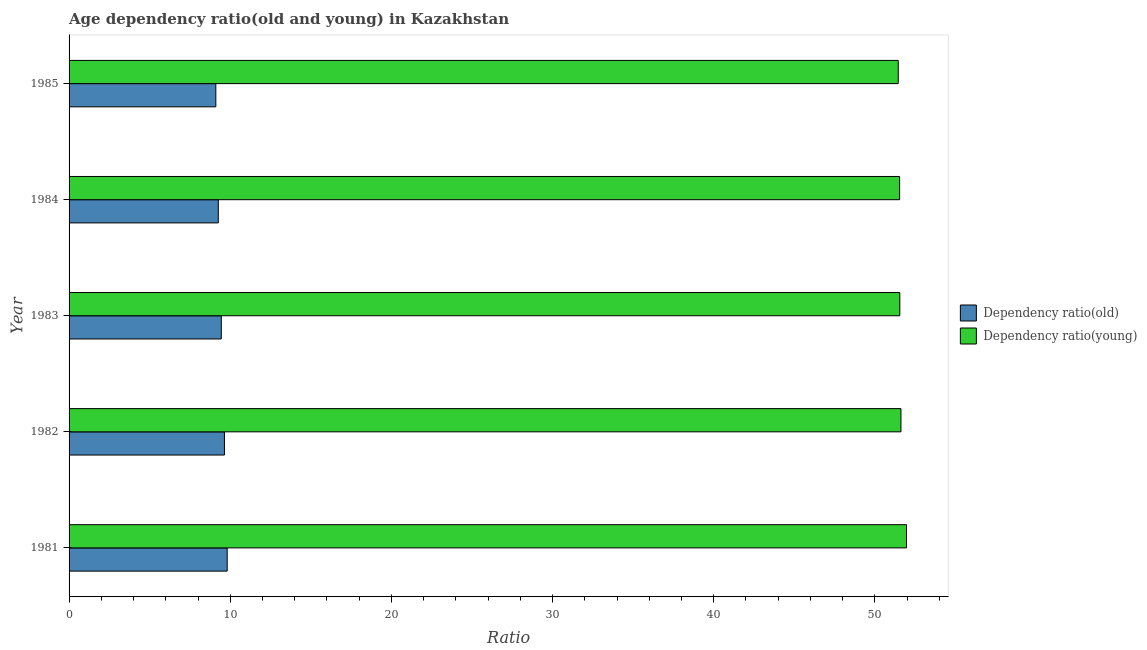How many different coloured bars are there?
Your answer should be compact. 2. How many groups of bars are there?
Offer a very short reply. 5. How many bars are there on the 4th tick from the bottom?
Keep it short and to the point. 2. What is the label of the 3rd group of bars from the top?
Provide a short and direct response. 1983. What is the age dependency ratio(young) in 1981?
Offer a terse response. 51.96. Across all years, what is the maximum age dependency ratio(old)?
Ensure brevity in your answer.  9.81. Across all years, what is the minimum age dependency ratio(old)?
Your answer should be compact. 9.11. In which year was the age dependency ratio(young) maximum?
Give a very brief answer. 1981. What is the total age dependency ratio(young) in the graph?
Your response must be concise. 258.12. What is the difference between the age dependency ratio(old) in 1983 and that in 1985?
Ensure brevity in your answer.  0.34. What is the difference between the age dependency ratio(young) in 1981 and the age dependency ratio(old) in 1984?
Make the answer very short. 42.7. What is the average age dependency ratio(old) per year?
Keep it short and to the point. 9.45. In the year 1981, what is the difference between the age dependency ratio(old) and age dependency ratio(young)?
Give a very brief answer. -42.15. In how many years, is the age dependency ratio(young) greater than 44 ?
Offer a terse response. 5. Is the age dependency ratio(old) in 1982 less than that in 1984?
Provide a short and direct response. No. Is the difference between the age dependency ratio(young) in 1982 and 1983 greater than the difference between the age dependency ratio(old) in 1982 and 1983?
Give a very brief answer. No. What is the difference between the highest and the second highest age dependency ratio(young)?
Provide a succinct answer. 0.34. What is the difference between the highest and the lowest age dependency ratio(young)?
Offer a terse response. 0.51. In how many years, is the age dependency ratio(young) greater than the average age dependency ratio(young) taken over all years?
Provide a succinct answer. 1. Is the sum of the age dependency ratio(young) in 1983 and 1985 greater than the maximum age dependency ratio(old) across all years?
Keep it short and to the point. Yes. What does the 2nd bar from the top in 1984 represents?
Make the answer very short. Dependency ratio(old). What does the 1st bar from the bottom in 1985 represents?
Your answer should be compact. Dependency ratio(old). How many years are there in the graph?
Provide a succinct answer. 5. Are the values on the major ticks of X-axis written in scientific E-notation?
Ensure brevity in your answer.  No. Does the graph contain any zero values?
Provide a succinct answer. No. What is the title of the graph?
Provide a succinct answer. Age dependency ratio(old and young) in Kazakhstan. Does "Researchers" appear as one of the legend labels in the graph?
Keep it short and to the point. No. What is the label or title of the X-axis?
Provide a succinct answer. Ratio. What is the label or title of the Y-axis?
Keep it short and to the point. Year. What is the Ratio in Dependency ratio(old) in 1981?
Your answer should be very brief. 9.81. What is the Ratio of Dependency ratio(young) in 1981?
Offer a very short reply. 51.96. What is the Ratio of Dependency ratio(old) in 1982?
Provide a succinct answer. 9.64. What is the Ratio in Dependency ratio(young) in 1982?
Your answer should be compact. 51.62. What is the Ratio of Dependency ratio(old) in 1983?
Provide a short and direct response. 9.45. What is the Ratio in Dependency ratio(young) in 1983?
Provide a succinct answer. 51.55. What is the Ratio in Dependency ratio(old) in 1984?
Give a very brief answer. 9.26. What is the Ratio in Dependency ratio(young) in 1984?
Ensure brevity in your answer.  51.54. What is the Ratio of Dependency ratio(old) in 1985?
Keep it short and to the point. 9.11. What is the Ratio in Dependency ratio(young) in 1985?
Provide a short and direct response. 51.45. Across all years, what is the maximum Ratio in Dependency ratio(old)?
Your answer should be compact. 9.81. Across all years, what is the maximum Ratio in Dependency ratio(young)?
Provide a succinct answer. 51.96. Across all years, what is the minimum Ratio in Dependency ratio(old)?
Offer a terse response. 9.11. Across all years, what is the minimum Ratio of Dependency ratio(young)?
Offer a terse response. 51.45. What is the total Ratio in Dependency ratio(old) in the graph?
Offer a very short reply. 47.27. What is the total Ratio of Dependency ratio(young) in the graph?
Make the answer very short. 258.12. What is the difference between the Ratio in Dependency ratio(old) in 1981 and that in 1982?
Your answer should be compact. 0.17. What is the difference between the Ratio in Dependency ratio(young) in 1981 and that in 1982?
Keep it short and to the point. 0.34. What is the difference between the Ratio in Dependency ratio(old) in 1981 and that in 1983?
Offer a very short reply. 0.37. What is the difference between the Ratio of Dependency ratio(young) in 1981 and that in 1983?
Your answer should be very brief. 0.41. What is the difference between the Ratio in Dependency ratio(old) in 1981 and that in 1984?
Give a very brief answer. 0.55. What is the difference between the Ratio of Dependency ratio(young) in 1981 and that in 1984?
Offer a very short reply. 0.43. What is the difference between the Ratio in Dependency ratio(old) in 1981 and that in 1985?
Your answer should be very brief. 0.7. What is the difference between the Ratio of Dependency ratio(young) in 1981 and that in 1985?
Provide a succinct answer. 0.51. What is the difference between the Ratio in Dependency ratio(old) in 1982 and that in 1983?
Keep it short and to the point. 0.2. What is the difference between the Ratio in Dependency ratio(young) in 1982 and that in 1983?
Keep it short and to the point. 0.07. What is the difference between the Ratio of Dependency ratio(old) in 1982 and that in 1984?
Offer a terse response. 0.38. What is the difference between the Ratio of Dependency ratio(young) in 1982 and that in 1984?
Offer a very short reply. 0.08. What is the difference between the Ratio of Dependency ratio(old) in 1982 and that in 1985?
Provide a short and direct response. 0.54. What is the difference between the Ratio in Dependency ratio(young) in 1982 and that in 1985?
Your answer should be very brief. 0.17. What is the difference between the Ratio in Dependency ratio(old) in 1983 and that in 1984?
Provide a short and direct response. 0.19. What is the difference between the Ratio of Dependency ratio(young) in 1983 and that in 1984?
Ensure brevity in your answer.  0.01. What is the difference between the Ratio in Dependency ratio(old) in 1983 and that in 1985?
Your answer should be compact. 0.34. What is the difference between the Ratio in Dependency ratio(young) in 1983 and that in 1985?
Keep it short and to the point. 0.1. What is the difference between the Ratio in Dependency ratio(old) in 1984 and that in 1985?
Make the answer very short. 0.15. What is the difference between the Ratio of Dependency ratio(young) in 1984 and that in 1985?
Your response must be concise. 0.09. What is the difference between the Ratio of Dependency ratio(old) in 1981 and the Ratio of Dependency ratio(young) in 1982?
Keep it short and to the point. -41.81. What is the difference between the Ratio in Dependency ratio(old) in 1981 and the Ratio in Dependency ratio(young) in 1983?
Provide a short and direct response. -41.74. What is the difference between the Ratio of Dependency ratio(old) in 1981 and the Ratio of Dependency ratio(young) in 1984?
Keep it short and to the point. -41.73. What is the difference between the Ratio of Dependency ratio(old) in 1981 and the Ratio of Dependency ratio(young) in 1985?
Your answer should be compact. -41.64. What is the difference between the Ratio of Dependency ratio(old) in 1982 and the Ratio of Dependency ratio(young) in 1983?
Ensure brevity in your answer.  -41.91. What is the difference between the Ratio in Dependency ratio(old) in 1982 and the Ratio in Dependency ratio(young) in 1984?
Offer a terse response. -41.9. What is the difference between the Ratio of Dependency ratio(old) in 1982 and the Ratio of Dependency ratio(young) in 1985?
Your answer should be compact. -41.81. What is the difference between the Ratio of Dependency ratio(old) in 1983 and the Ratio of Dependency ratio(young) in 1984?
Ensure brevity in your answer.  -42.09. What is the difference between the Ratio in Dependency ratio(old) in 1983 and the Ratio in Dependency ratio(young) in 1985?
Offer a terse response. -42.01. What is the difference between the Ratio in Dependency ratio(old) in 1984 and the Ratio in Dependency ratio(young) in 1985?
Provide a succinct answer. -42.19. What is the average Ratio of Dependency ratio(old) per year?
Offer a very short reply. 9.45. What is the average Ratio of Dependency ratio(young) per year?
Offer a terse response. 51.62. In the year 1981, what is the difference between the Ratio of Dependency ratio(old) and Ratio of Dependency ratio(young)?
Provide a succinct answer. -42.15. In the year 1982, what is the difference between the Ratio in Dependency ratio(old) and Ratio in Dependency ratio(young)?
Your answer should be compact. -41.98. In the year 1983, what is the difference between the Ratio in Dependency ratio(old) and Ratio in Dependency ratio(young)?
Make the answer very short. -42.1. In the year 1984, what is the difference between the Ratio in Dependency ratio(old) and Ratio in Dependency ratio(young)?
Your response must be concise. -42.28. In the year 1985, what is the difference between the Ratio of Dependency ratio(old) and Ratio of Dependency ratio(young)?
Offer a very short reply. -42.34. What is the ratio of the Ratio in Dependency ratio(old) in 1981 to that in 1982?
Make the answer very short. 1.02. What is the ratio of the Ratio in Dependency ratio(young) in 1981 to that in 1982?
Your response must be concise. 1.01. What is the ratio of the Ratio in Dependency ratio(old) in 1981 to that in 1983?
Give a very brief answer. 1.04. What is the ratio of the Ratio of Dependency ratio(old) in 1981 to that in 1984?
Offer a terse response. 1.06. What is the ratio of the Ratio of Dependency ratio(young) in 1981 to that in 1984?
Your response must be concise. 1.01. What is the ratio of the Ratio of Dependency ratio(old) in 1981 to that in 1985?
Offer a very short reply. 1.08. What is the ratio of the Ratio of Dependency ratio(young) in 1981 to that in 1985?
Your answer should be compact. 1.01. What is the ratio of the Ratio in Dependency ratio(old) in 1982 to that in 1983?
Make the answer very short. 1.02. What is the ratio of the Ratio in Dependency ratio(young) in 1982 to that in 1983?
Provide a succinct answer. 1. What is the ratio of the Ratio of Dependency ratio(old) in 1982 to that in 1984?
Your response must be concise. 1.04. What is the ratio of the Ratio of Dependency ratio(young) in 1982 to that in 1984?
Give a very brief answer. 1. What is the ratio of the Ratio in Dependency ratio(old) in 1982 to that in 1985?
Give a very brief answer. 1.06. What is the ratio of the Ratio of Dependency ratio(young) in 1982 to that in 1985?
Your answer should be compact. 1. What is the ratio of the Ratio in Dependency ratio(old) in 1983 to that in 1984?
Provide a short and direct response. 1.02. What is the ratio of the Ratio of Dependency ratio(old) in 1983 to that in 1985?
Give a very brief answer. 1.04. What is the ratio of the Ratio of Dependency ratio(young) in 1983 to that in 1985?
Offer a very short reply. 1. What is the ratio of the Ratio of Dependency ratio(old) in 1984 to that in 1985?
Offer a very short reply. 1.02. What is the difference between the highest and the second highest Ratio of Dependency ratio(old)?
Provide a short and direct response. 0.17. What is the difference between the highest and the second highest Ratio in Dependency ratio(young)?
Offer a very short reply. 0.34. What is the difference between the highest and the lowest Ratio of Dependency ratio(old)?
Offer a very short reply. 0.7. What is the difference between the highest and the lowest Ratio of Dependency ratio(young)?
Ensure brevity in your answer.  0.51. 